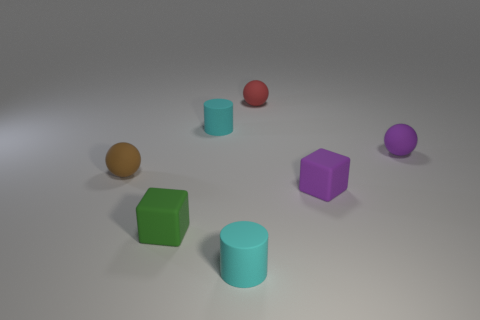Subtract 1 balls. How many balls are left? 2 Add 2 large brown rubber cylinders. How many objects exist? 9 Subtract all blocks. How many objects are left? 5 Subtract all small green balls. Subtract all matte objects. How many objects are left? 0 Add 7 green blocks. How many green blocks are left? 8 Add 1 small gray things. How many small gray things exist? 1 Subtract 0 red blocks. How many objects are left? 7 